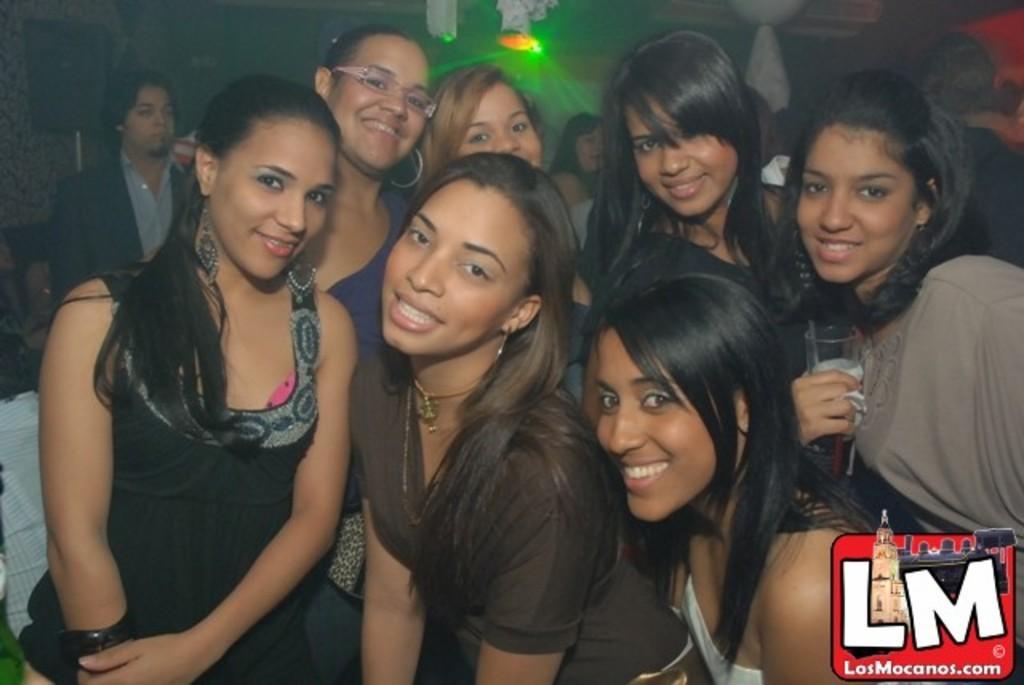Could you give a brief overview of what you see in this image? In this image I can see number of women. In the background I can see a person standing, few white and red colored objects and few lights. 